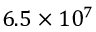Convert formula to latex. <formula><loc_0><loc_0><loc_500><loc_500>6 . 5 \times 1 0 ^ { 7 }</formula> 